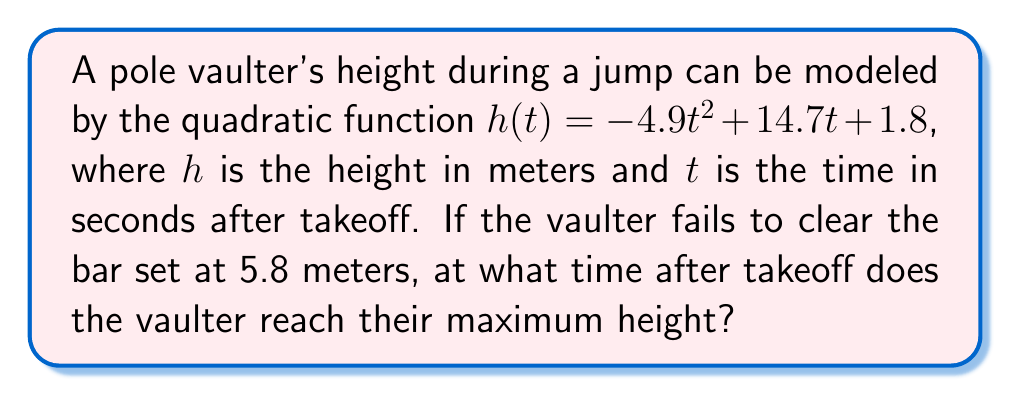Provide a solution to this math problem. To find the time when the vaulter reaches maximum height, we need to follow these steps:

1) The quadratic function given is: $h(t) = -4.9t^2 + 14.7t + 1.8$

2) For a quadratic function in the form $f(x) = ax^2 + bx + c$, the x-coordinate of the vertex (which represents the maximum or minimum point) is given by $x = -\frac{b}{2a}$

3) In our case, $a = -4.9$ and $b = 14.7$

4) Substituting these values:

   $t = -\frac{14.7}{2(-4.9)} = \frac{14.7}{9.8} = 1.5$

5) Therefore, the vaulter reaches maximum height 1.5 seconds after takeoff.

Note: We don't need to calculate the actual maximum height to answer this question.
Answer: 1.5 seconds 